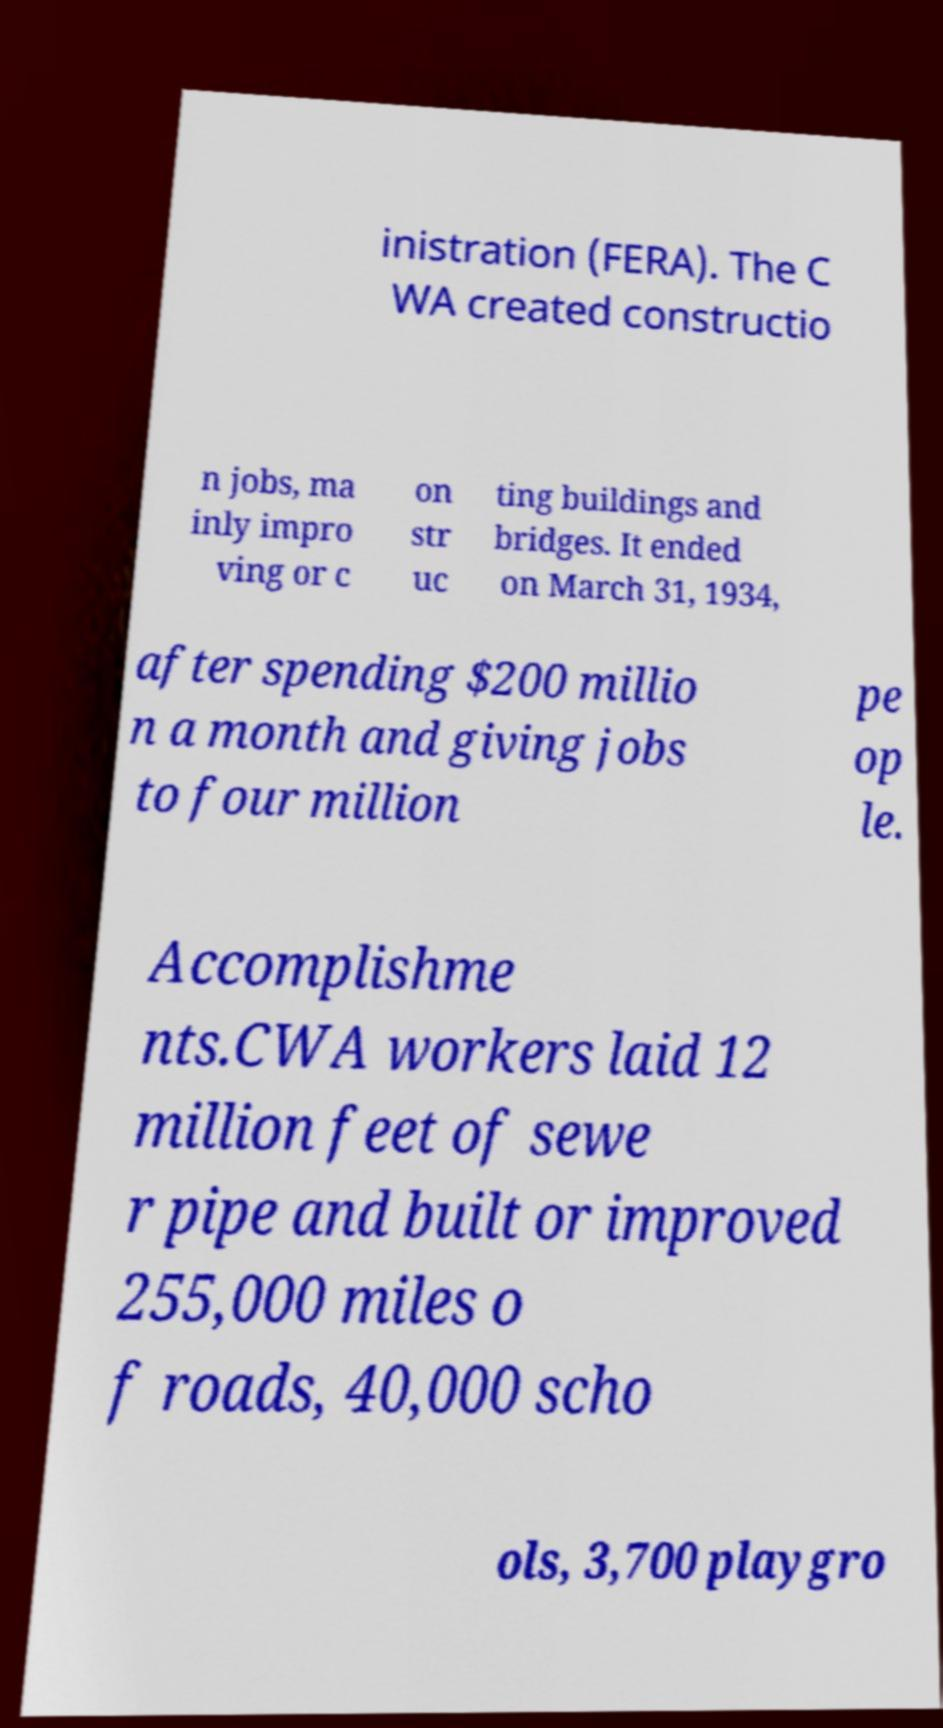What messages or text are displayed in this image? I need them in a readable, typed format. inistration (FERA). The C WA created constructio n jobs, ma inly impro ving or c on str uc ting buildings and bridges. It ended on March 31, 1934, after spending $200 millio n a month and giving jobs to four million pe op le. Accomplishme nts.CWA workers laid 12 million feet of sewe r pipe and built or improved 255,000 miles o f roads, 40,000 scho ols, 3,700 playgro 